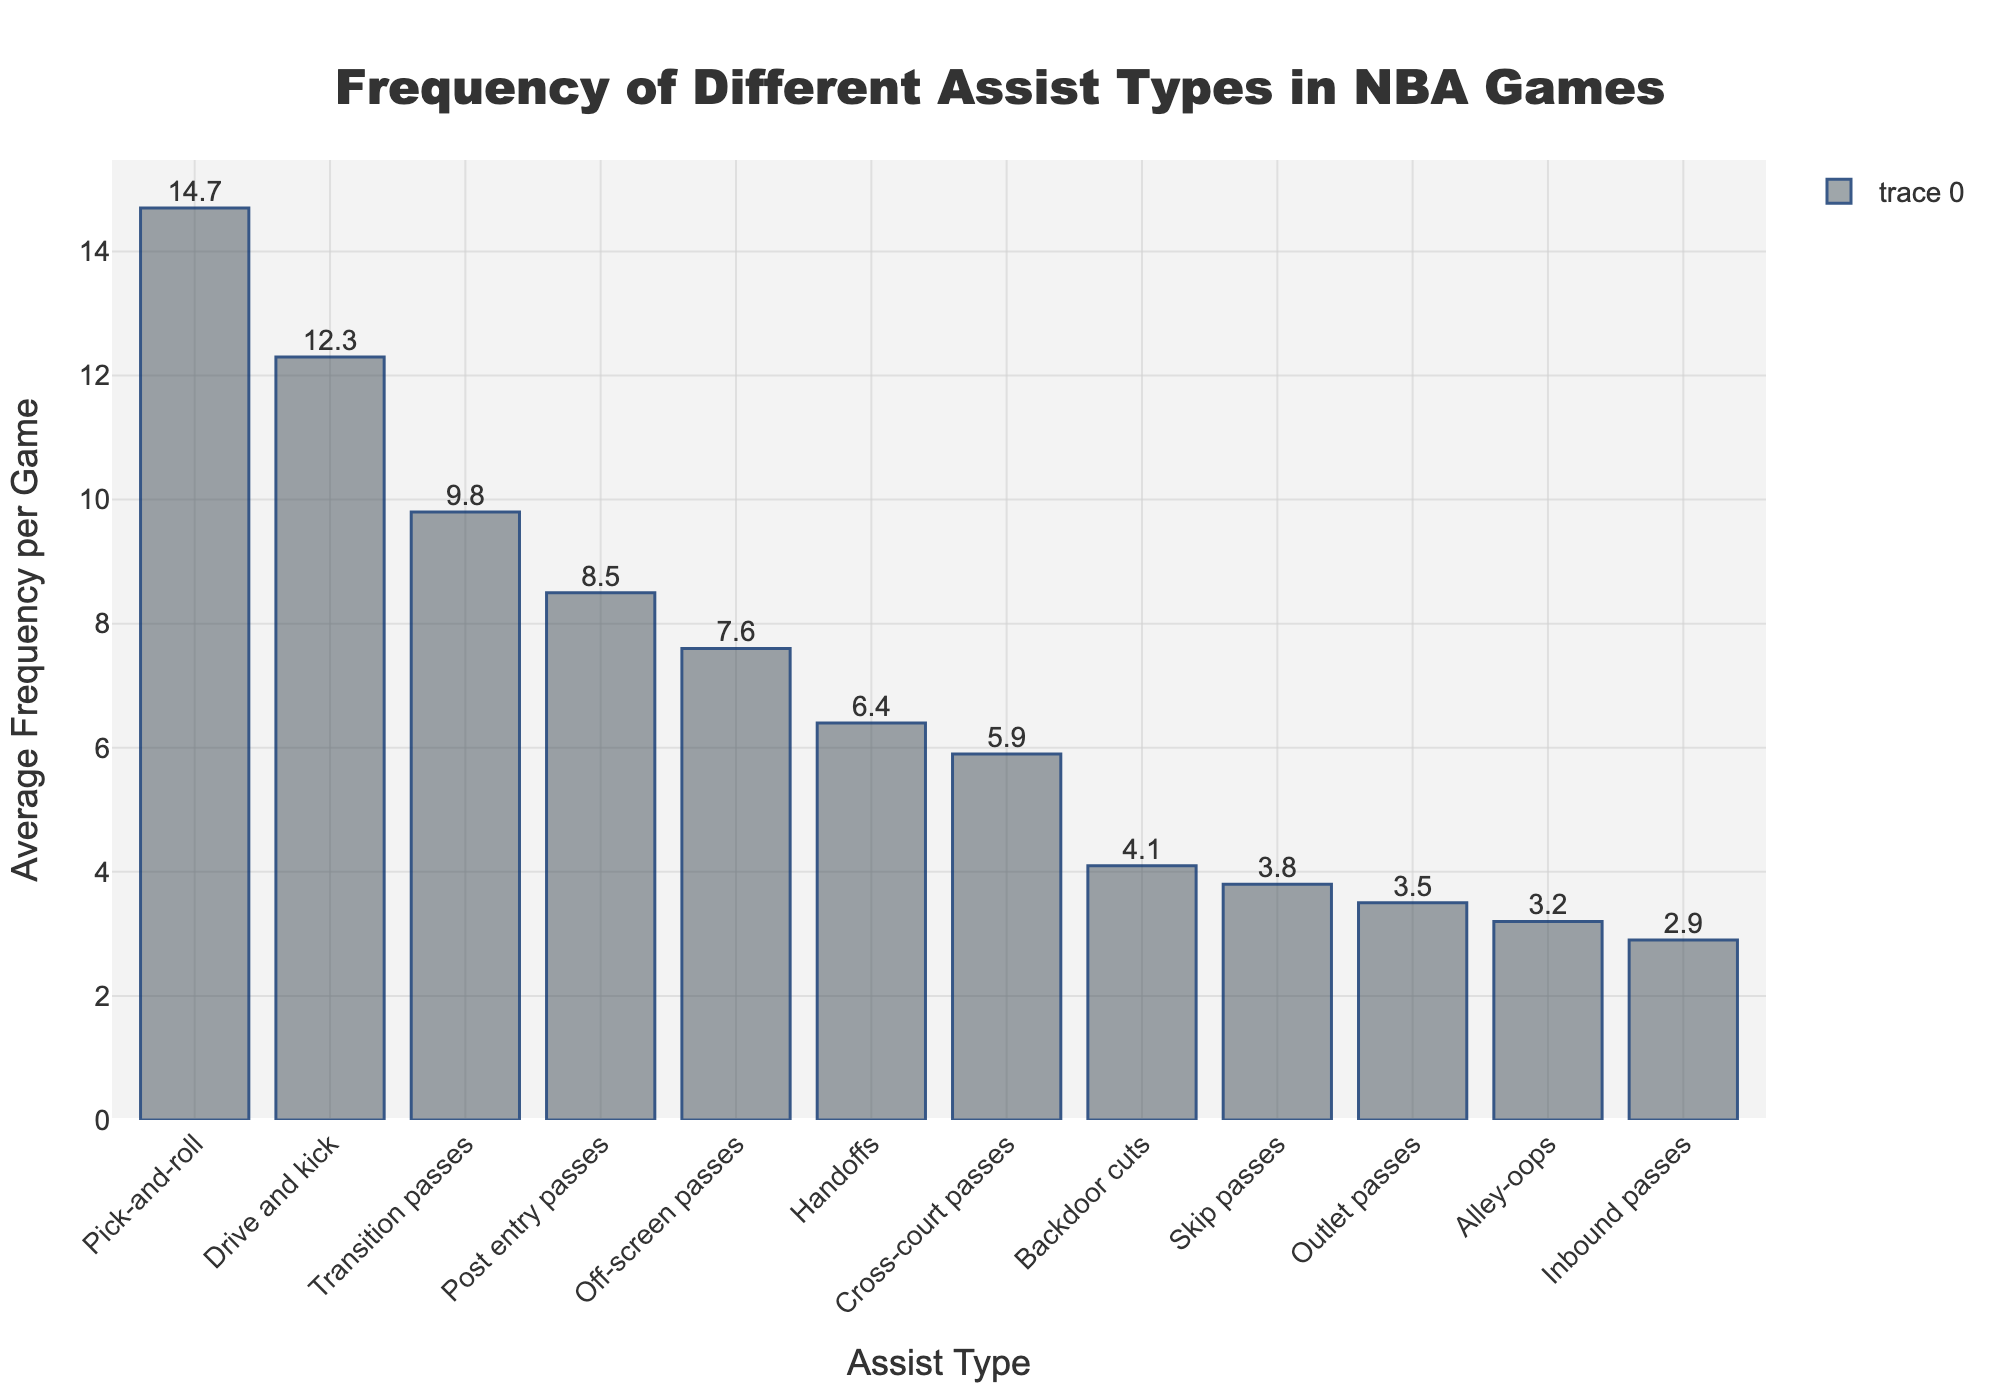what is the total number of assists per game for 'Pick-and-roll' and 'Drive and kick'? To find the total number of assists per game for 'Pick-and-roll' and 'Drive and kick', we sum their respective frequencies: 14.7 (Pick-and-roll) + 12.3 (Drive and kick) = 27.0
Answer: 27.0 Which assist type has the lowest average frequency per game? By looking at the bar heights, 'Inbound passes' has the shortest bar, indicating the lowest average frequency of 2.9 per game
Answer: Inbound passes How many more times frequent are 'Transition passes' compared to 'Outlet passes'? To find how many more times 'Transition passes' are compared to 'Outlet passes', we subtract their frequencies: 9.8 (Transition passes) - 3.5 (Outlet passes) = 6.3
Answer: 6.3 Which assist type is the most frequent and what is its frequency? The tallest bar corresponds to 'Pick-and-roll' with a frequency of 14.7 per game
Answer: Pick-and-roll, 14.7 Arrange the assist types from highest to lowest frequency. The order from the bars' heights is: Pick-and-roll (14.7), Drive and kick (12.3), Transition passes (9.8), Post entry passes (8.5), Off-screen passes (7.6), Handoffs (6.4), Cross-court passes (5.9), Backdoor cuts (4.1), Skip passes (3.8), Outlet passes (3.5), Alley-oops (3.2), Inbound passes (2.9)
Answer: Pick-and-roll, Drive and kick, Transition passes, Post entry passes, Off-screen passes, Handoffs, Cross-court passes, Backdoor cuts, Skip passes, Outlet passes, Alley-oops, Inbound passes What is the combined average frequency per game for 'Alley-oops', 'Skip passes' and 'Outlet passes'? Sum their respective frequencies: 3.2 (Alley-oops) + 3.8 (Skip passes) + 3.5 (Outlet passes) = 10.5
Answer: 10.5 How much more frequent is 'Post entry passes' compared to 'Cross-court passes'? Subtract the frequency of 'Cross-court passes' from 'Post entry passes': 8.5 (Post entry passes) - 5.9 (Cross-court passes) = 2.6
Answer: 2.6 Which assist types have a frequency higher than 10 per game? Looking at bars with heights greater than 10, 'Pick-and-roll' (14.7) and 'Drive and kick' (12.3) have frequencies higher than 10
Answer: Pick-and-roll, Drive and kick 